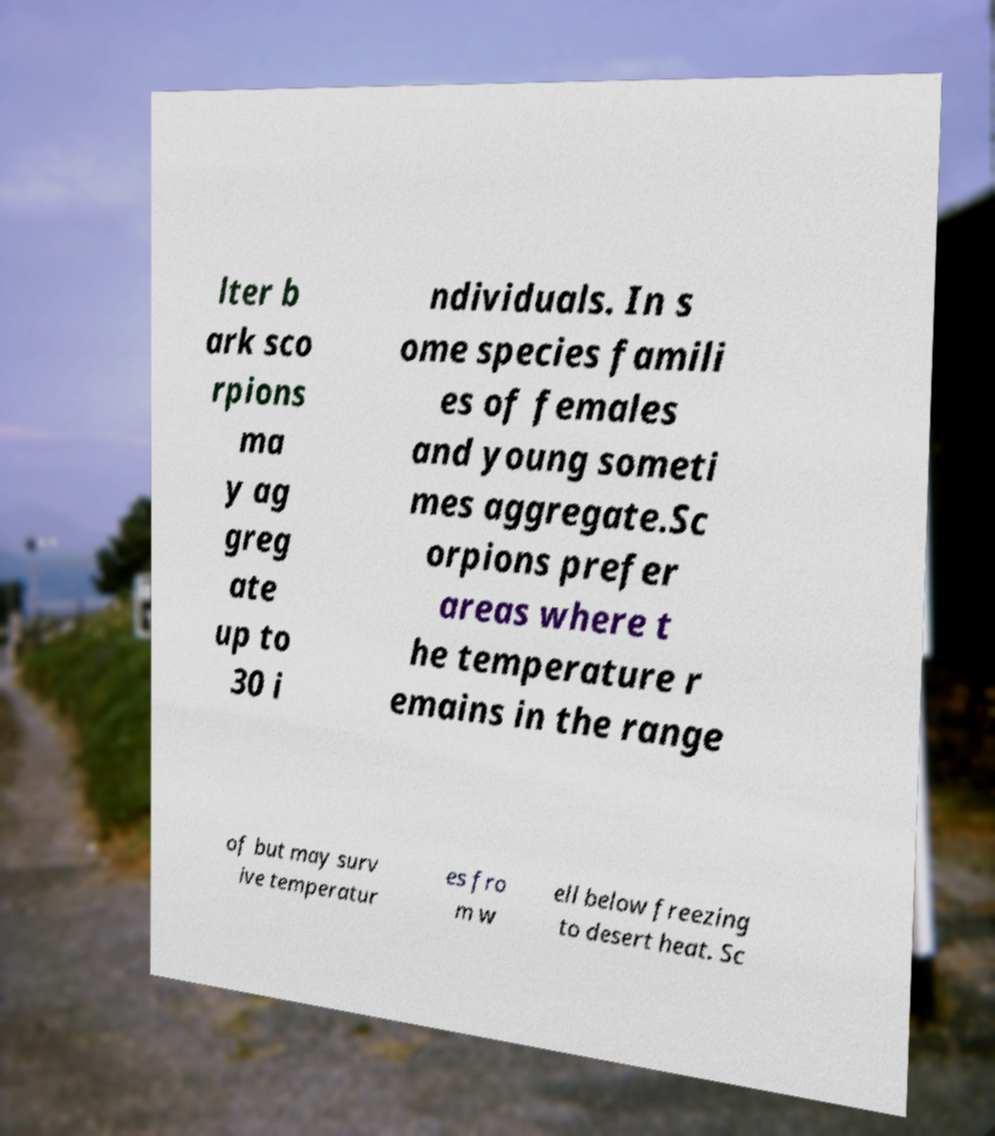Could you extract and type out the text from this image? lter b ark sco rpions ma y ag greg ate up to 30 i ndividuals. In s ome species famili es of females and young someti mes aggregate.Sc orpions prefer areas where t he temperature r emains in the range of but may surv ive temperatur es fro m w ell below freezing to desert heat. Sc 